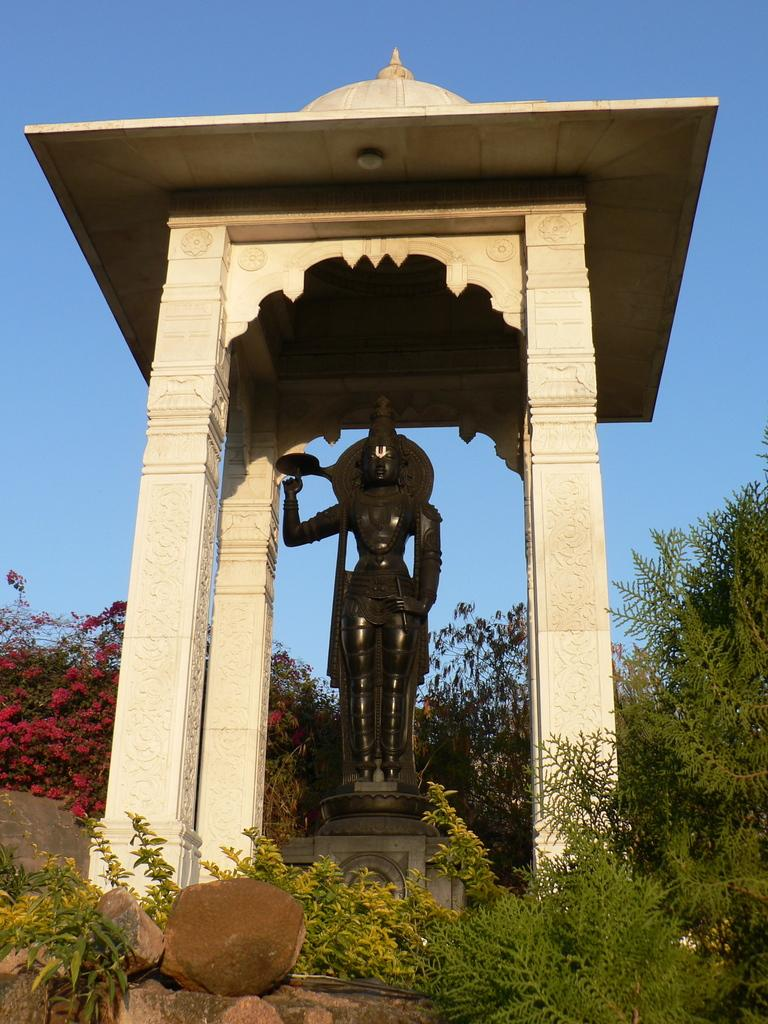What is the main subject in the image? There is a statue in the image. What architectural features can be seen in the image? There are pillars in the image. What type of vegetation is present in the image? There are plants and trees in the image. What type of ground surface is visible in the image? There are stones in the image. What is visible in the background of the image? The sky is visible in the background of the image. Can you see a hen walking through the quicksand in the image? There is no hen or quicksand present in the image. What type of light source is illuminating the statue in the image? The provided facts do not mention any light source; we can only see the statue, pillars, plants, trees, stones, and sky. 